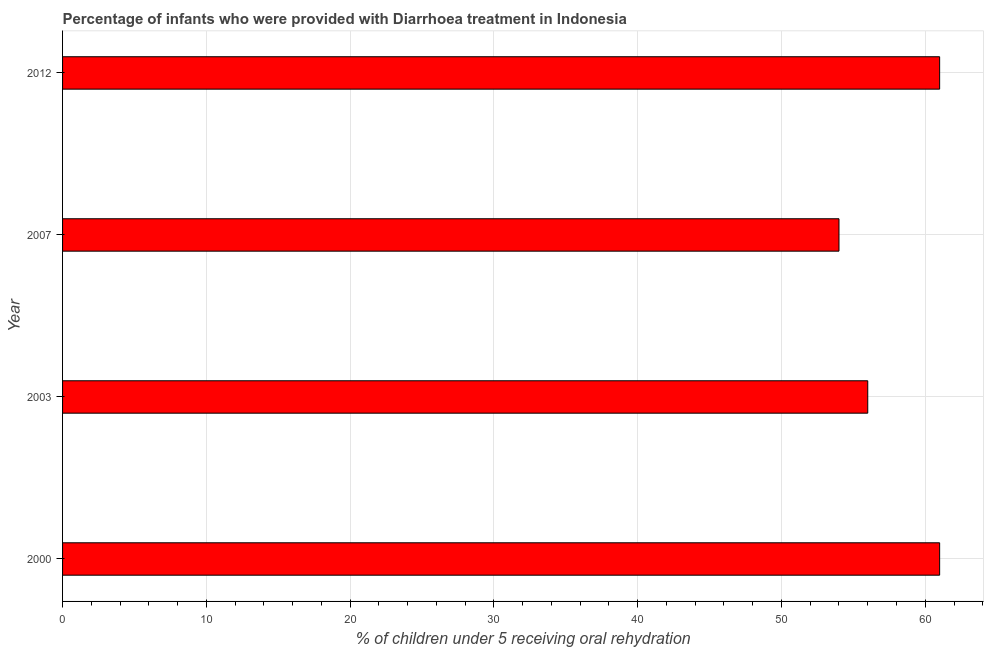Does the graph contain any zero values?
Provide a short and direct response. No. What is the title of the graph?
Offer a very short reply. Percentage of infants who were provided with Diarrhoea treatment in Indonesia. What is the label or title of the X-axis?
Offer a terse response. % of children under 5 receiving oral rehydration. What is the percentage of children who were provided with treatment diarrhoea in 2000?
Offer a very short reply. 61. Across all years, what is the minimum percentage of children who were provided with treatment diarrhoea?
Offer a very short reply. 54. In which year was the percentage of children who were provided with treatment diarrhoea minimum?
Make the answer very short. 2007. What is the sum of the percentage of children who were provided with treatment diarrhoea?
Provide a succinct answer. 232. What is the difference between the percentage of children who were provided with treatment diarrhoea in 2003 and 2007?
Ensure brevity in your answer.  2. What is the average percentage of children who were provided with treatment diarrhoea per year?
Give a very brief answer. 58. What is the median percentage of children who were provided with treatment diarrhoea?
Ensure brevity in your answer.  58.5. In how many years, is the percentage of children who were provided with treatment diarrhoea greater than 60 %?
Your answer should be compact. 2. What is the ratio of the percentage of children who were provided with treatment diarrhoea in 2003 to that in 2012?
Ensure brevity in your answer.  0.92. Is the difference between the percentage of children who were provided with treatment diarrhoea in 2000 and 2003 greater than the difference between any two years?
Ensure brevity in your answer.  No. Is the sum of the percentage of children who were provided with treatment diarrhoea in 2003 and 2012 greater than the maximum percentage of children who were provided with treatment diarrhoea across all years?
Your answer should be very brief. Yes. What is the difference between the highest and the lowest percentage of children who were provided with treatment diarrhoea?
Give a very brief answer. 7. How many bars are there?
Make the answer very short. 4. Are all the bars in the graph horizontal?
Ensure brevity in your answer.  Yes. How many years are there in the graph?
Give a very brief answer. 4. What is the difference between two consecutive major ticks on the X-axis?
Keep it short and to the point. 10. What is the % of children under 5 receiving oral rehydration in 2000?
Provide a short and direct response. 61. What is the % of children under 5 receiving oral rehydration of 2012?
Your response must be concise. 61. What is the difference between the % of children under 5 receiving oral rehydration in 2000 and 2007?
Make the answer very short. 7. What is the difference between the % of children under 5 receiving oral rehydration in 2000 and 2012?
Your answer should be very brief. 0. What is the difference between the % of children under 5 receiving oral rehydration in 2007 and 2012?
Offer a very short reply. -7. What is the ratio of the % of children under 5 receiving oral rehydration in 2000 to that in 2003?
Offer a terse response. 1.09. What is the ratio of the % of children under 5 receiving oral rehydration in 2000 to that in 2007?
Keep it short and to the point. 1.13. What is the ratio of the % of children under 5 receiving oral rehydration in 2000 to that in 2012?
Offer a terse response. 1. What is the ratio of the % of children under 5 receiving oral rehydration in 2003 to that in 2012?
Offer a terse response. 0.92. What is the ratio of the % of children under 5 receiving oral rehydration in 2007 to that in 2012?
Give a very brief answer. 0.89. 